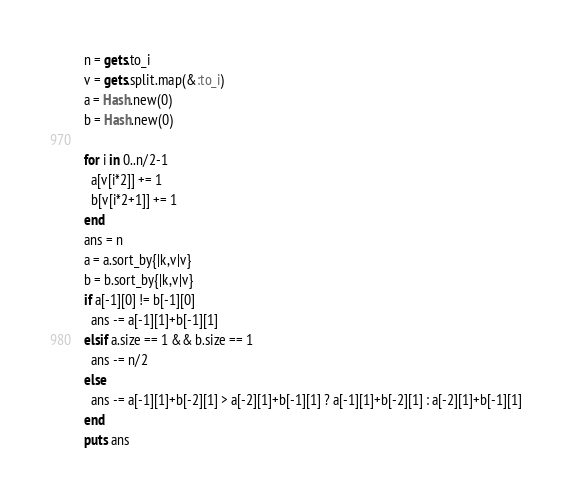Convert code to text. <code><loc_0><loc_0><loc_500><loc_500><_Ruby_>n = gets.to_i
v = gets.split.map(&:to_i)
a = Hash.new(0)
b = Hash.new(0)

for i in 0..n/2-1
  a[v[i*2]] += 1
  b[v[i*2+1]] += 1
end
ans = n
a = a.sort_by{|k,v|v}
b = b.sort_by{|k,v|v}
if a[-1][0] != b[-1][0]
  ans -= a[-1][1]+b[-1][1]
elsif a.size == 1 && b.size == 1
  ans -= n/2
else
  ans -= a[-1][1]+b[-2][1] > a[-2][1]+b[-1][1] ? a[-1][1]+b[-2][1] : a[-2][1]+b[-1][1]
end
puts ans</code> 